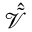<formula> <loc_0><loc_0><loc_500><loc_500>\mathcal { \hat { \tilde { V } } }</formula> 